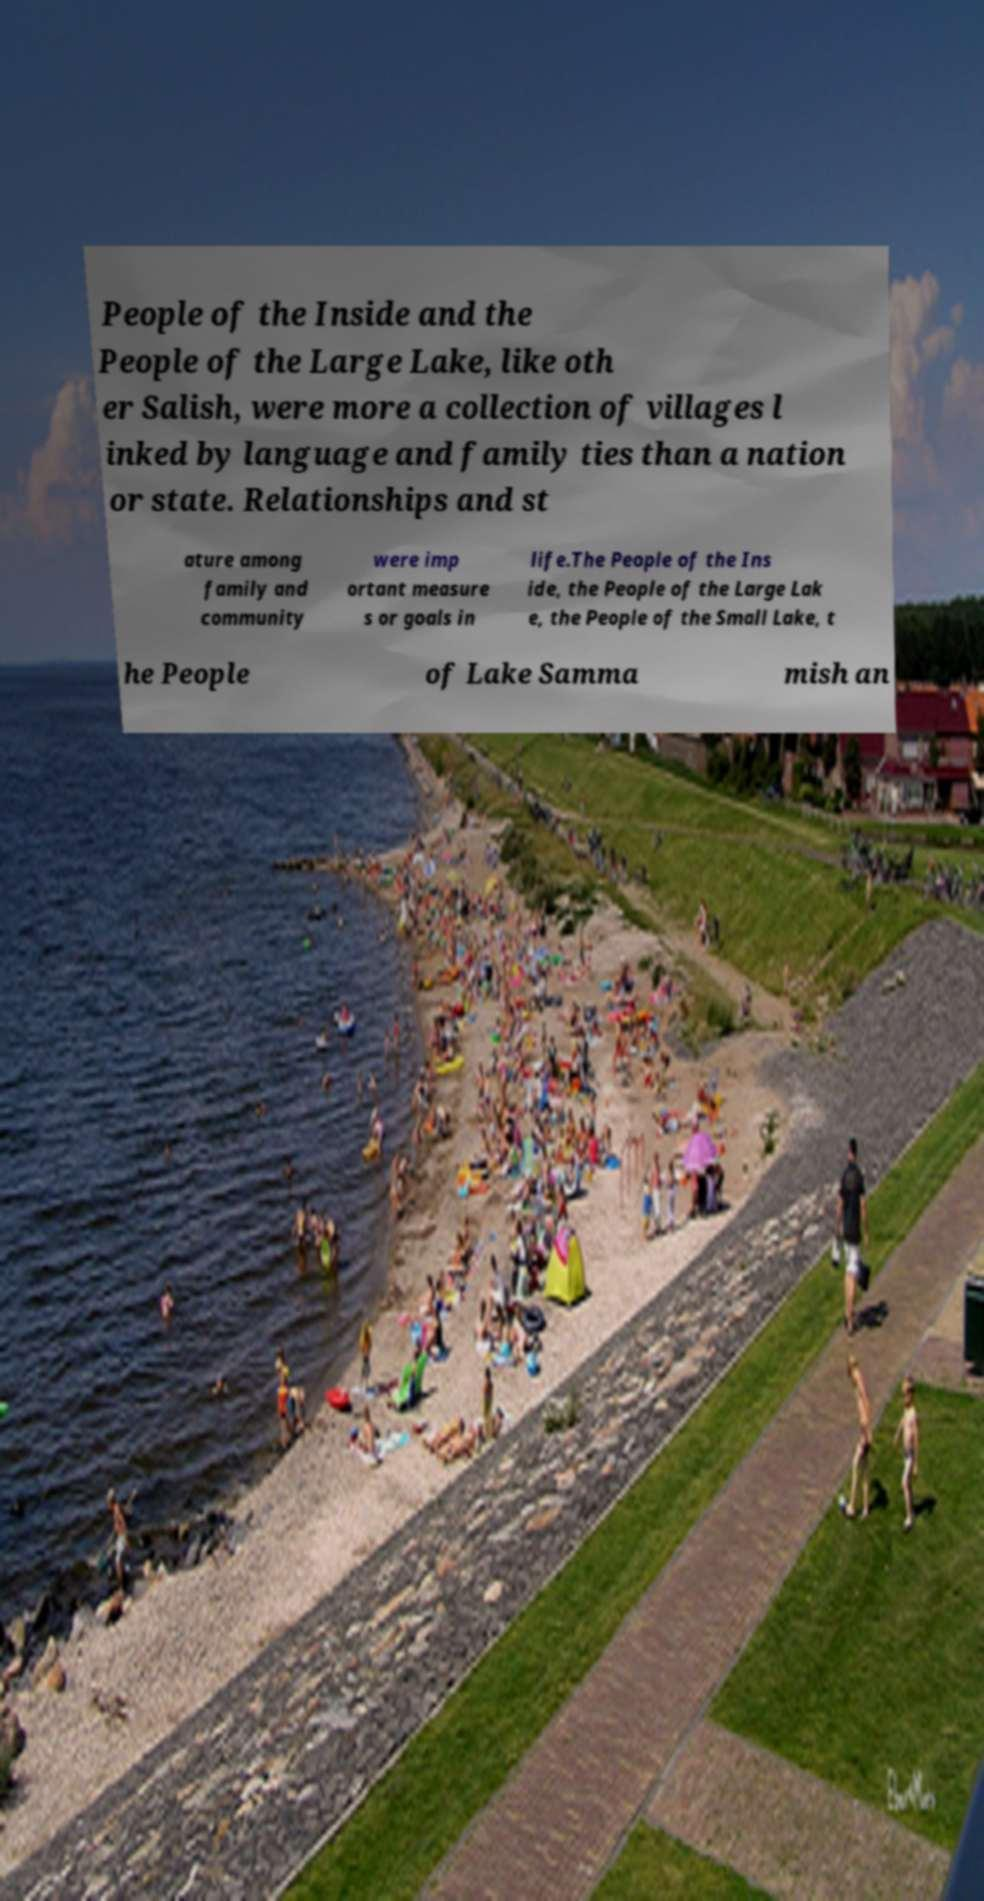Could you assist in decoding the text presented in this image and type it out clearly? People of the Inside and the People of the Large Lake, like oth er Salish, were more a collection of villages l inked by language and family ties than a nation or state. Relationships and st ature among family and community were imp ortant measure s or goals in life.The People of the Ins ide, the People of the Large Lak e, the People of the Small Lake, t he People of Lake Samma mish an 